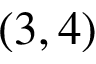<formula> <loc_0><loc_0><loc_500><loc_500>( 3 , 4 )</formula> 